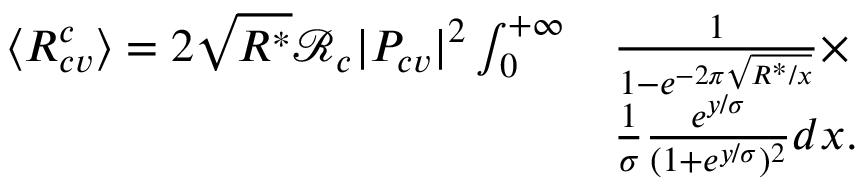Convert formula to latex. <formula><loc_0><loc_0><loc_500><loc_500>\begin{array} { r l } { \langle R _ { c v } ^ { c } \rangle = 2 \sqrt { R ^ { * } } \mathcal { R } _ { c } | P _ { c v } | ^ { 2 } \int _ { 0 } ^ { + \infty } } & { \frac { 1 } { 1 - e ^ { - 2 \pi \sqrt { R ^ { * } / x } } } \times } \\ & { \frac { 1 } { \sigma } \frac { e ^ { y / \sigma } } { ( 1 + e ^ { y / \sigma } ) ^ { 2 } } d x . } \end{array}</formula> 